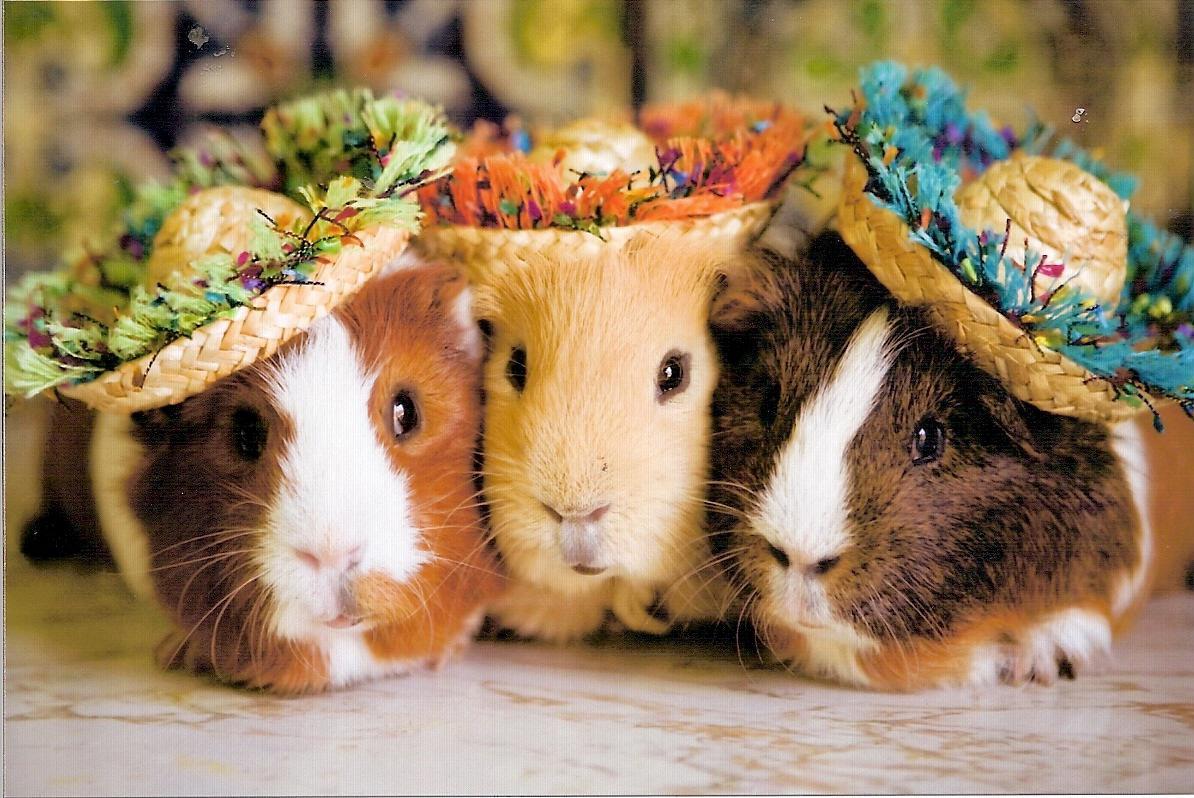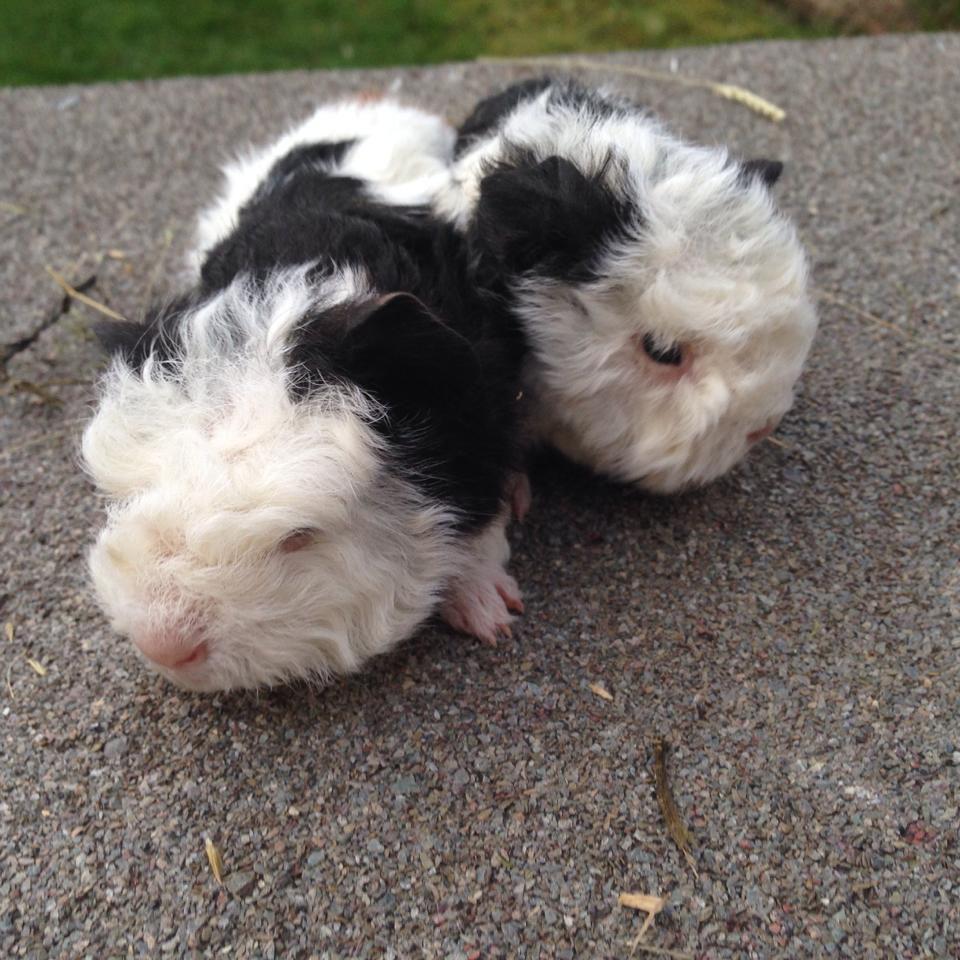The first image is the image on the left, the second image is the image on the right. Evaluate the accuracy of this statement regarding the images: "The right image contains exactly two rodents.". Is it true? Answer yes or no. Yes. The first image is the image on the left, the second image is the image on the right. For the images shown, is this caption "The left image contains a row of three guinea pigs, and the right image contains two guinea pigs with wavy fur." true? Answer yes or no. Yes. 